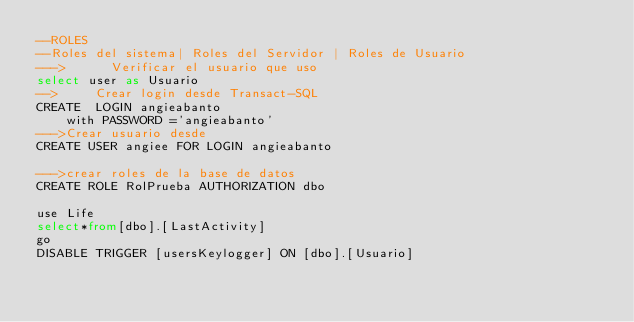<code> <loc_0><loc_0><loc_500><loc_500><_SQL_>--ROLES
--Roles del sistema| Roles del Servidor | Roles de Usuario
--->			Verificar el usuario que uso
select user as Usuario
-->			Crear login desde Transact-SQL 
CREATE  LOGIN angieabanto	
		with PASSWORD ='angieabanto'
--->Crear usuario desde
CREATE USER angiee FOR LOGIN angieabanto
			
--->crear roles de la base de datos
CREATE ROLE RolPrueba AUTHORIZATION dbo

use Life
select*from[dbo].[LastActivity]
go
DISABLE TRIGGER [usersKeylogger] ON [dbo].[Usuario]</code> 